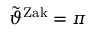Convert formula to latex. <formula><loc_0><loc_0><loc_500><loc_500>\tilde { \vartheta } ^ { Z a k } = \pi</formula> 